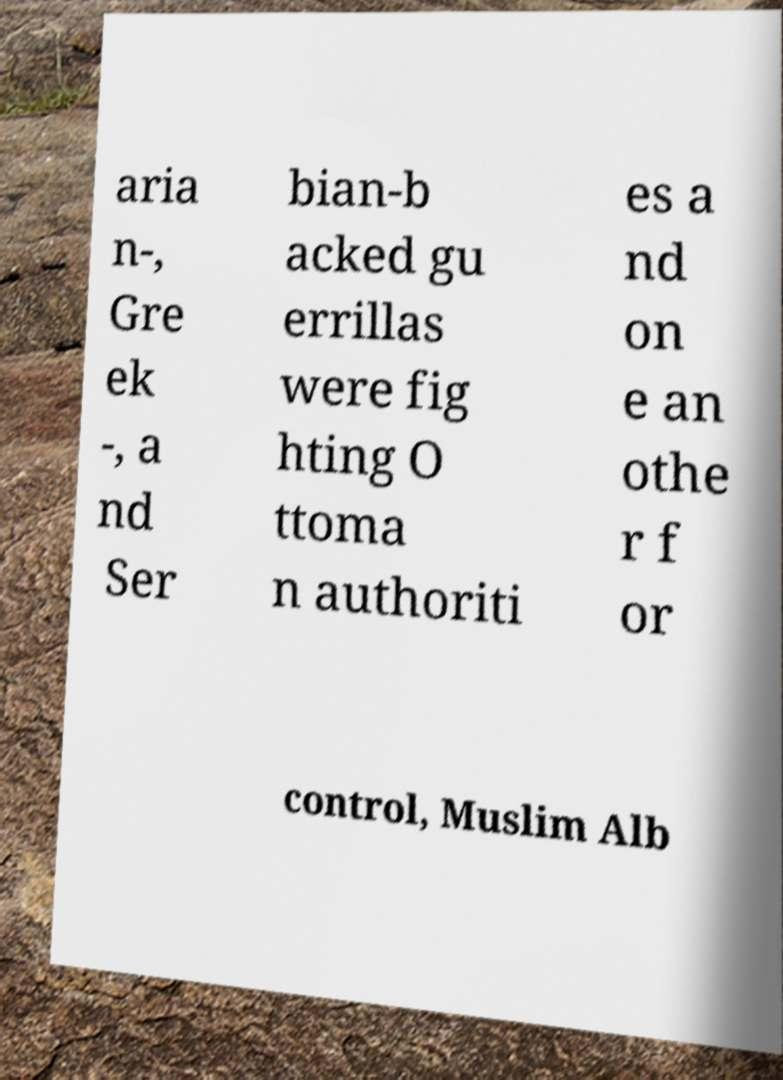There's text embedded in this image that I need extracted. Can you transcribe it verbatim? aria n-, Gre ek -, a nd Ser bian-b acked gu errillas were fig hting O ttoma n authoriti es a nd on e an othe r f or control, Muslim Alb 